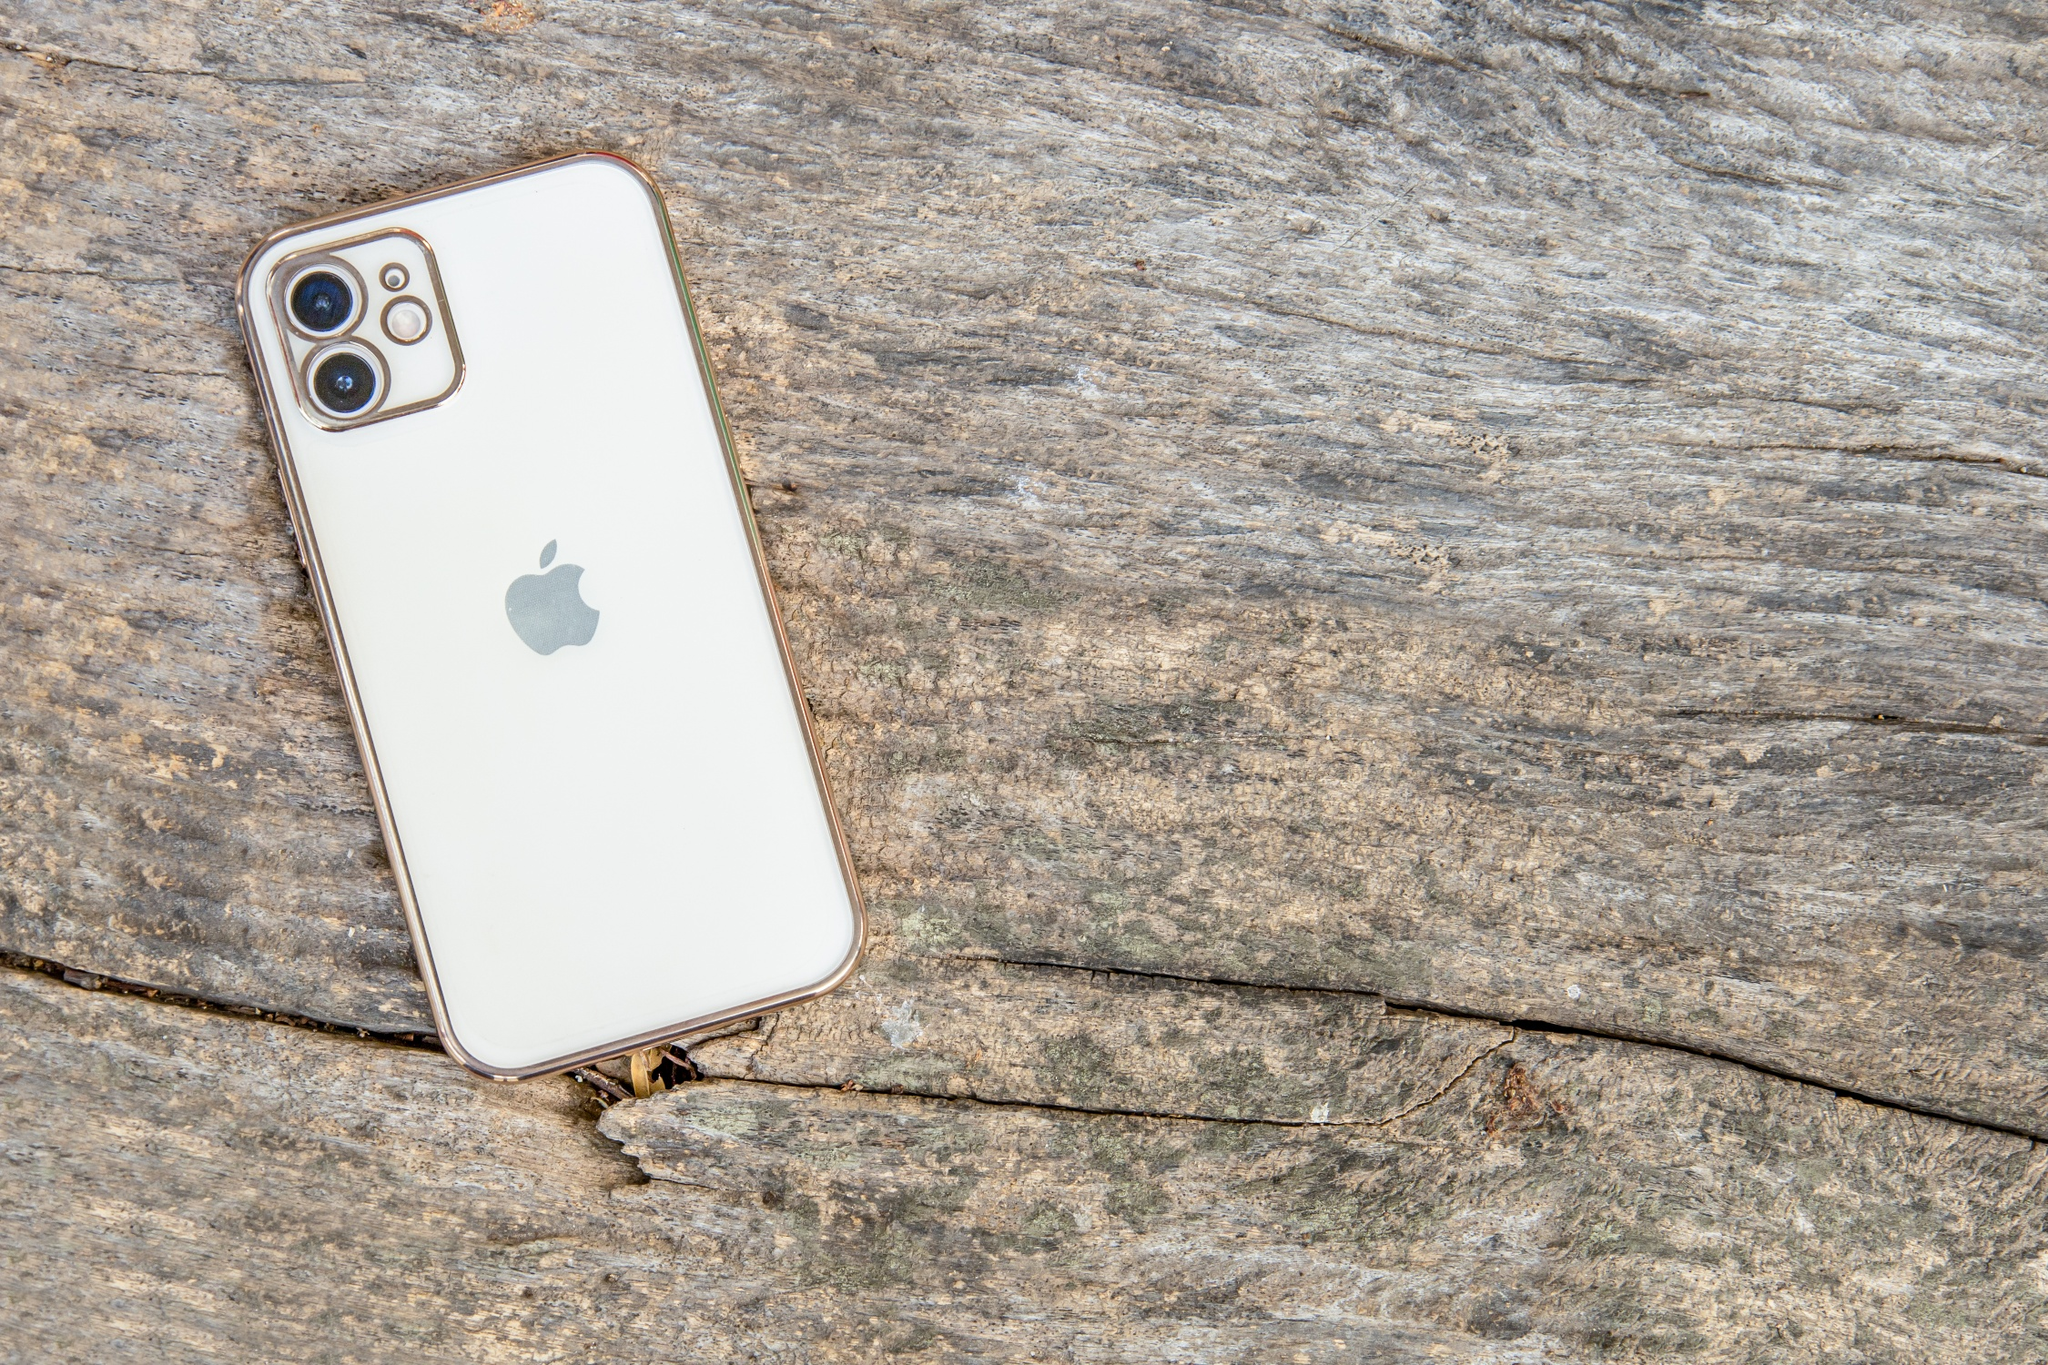If this image were used in an advertisement, what kind of product and message would it convey? This image would be ideal for an advertisement focusing on the durability and timeless design of the iPhone. The wooden surface, with its rugged texture and visible cracks, contrasts sharply with the sleek, flawless appearance of the iPhone, emphasizing the idea that while the world around us may age and show signs of wear, the iPhone remains a symbol of enduring quality and modern elegance. The message could be: 'iPhone – Timeless Elegance in a World of Change.' 